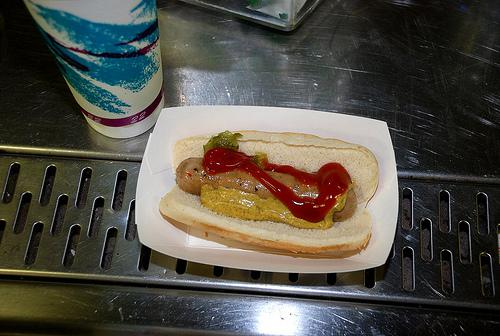Question: what food is in the photo?
Choices:
A. A hamburger.
B. A slice of cake.
C. A hot dog.
D. A sandwich.
Answer with the letter. Answer: C Question: what type of countertop is presented?
Choices:
A. Marble.
B. Wood.
C. Stainless steel.
D. Quartz.
Answer with the letter. Answer: C Question: how many toppings are on the hot dog?
Choices:
A. 12.
B. 13.
C. 5.
D. 2.
Answer with the letter. Answer: D 